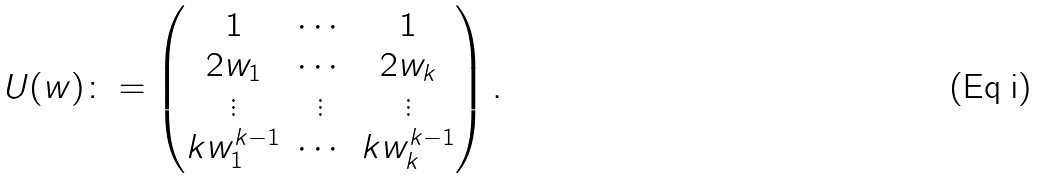Convert formula to latex. <formula><loc_0><loc_0><loc_500><loc_500>U ( w ) \colon = \begin{pmatrix} 1 & \cdots & 1 \\ 2 w _ { 1 } & \cdots & 2 w _ { k } \\ \vdots & \vdots & \vdots \\ k w _ { 1 } ^ { k - 1 } & \cdots & k w _ { k } ^ { k - 1 } \end{pmatrix} .</formula> 